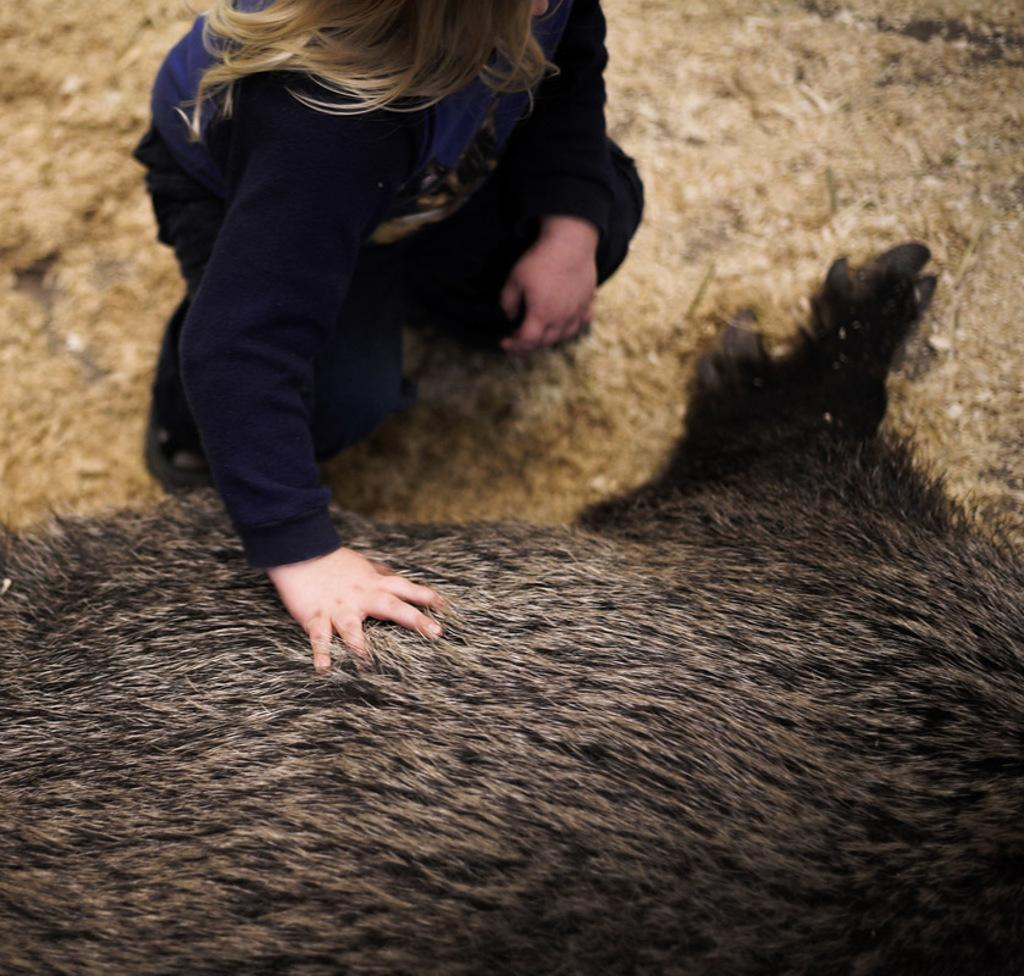What is the main subject of the image? There is a person in the image. What is the person doing in the image? The person is sitting beside an animal. How is the person interacting with the animal? The person is touching the animal. What is the position of the animal in the image? There is an animal lying on the ground in the foreground of the image. What type of twig is the person using to comb the animal's tongue in the image? There is no twig or combing action present in the image. The person is simply touching the animal, and there is no mention of a twig or the animal's tongue. 